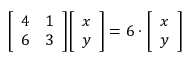Convert formula to latex. <formula><loc_0><loc_0><loc_500><loc_500>{ \left [ \begin{array} { l l } { 4 } & { 1 } \\ { 6 } & { 3 } \end{array} \right ] } { \left [ \begin{array} { l } { x } \\ { y } \end{array} \right ] } = 6 \cdot { \left [ \begin{array} { l } { x } \\ { y } \end{array} \right ] }</formula> 